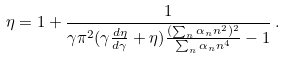<formula> <loc_0><loc_0><loc_500><loc_500>\eta = 1 + \frac { 1 } { \gamma \pi ^ { 2 } ( \gamma \frac { d \eta } { d \gamma } + \eta ) \frac { ( \sum _ { n } \alpha _ { n } n ^ { 2 } ) ^ { 2 } } { \sum _ { n } \alpha _ { n } n ^ { 4 } } - 1 } \, .</formula> 